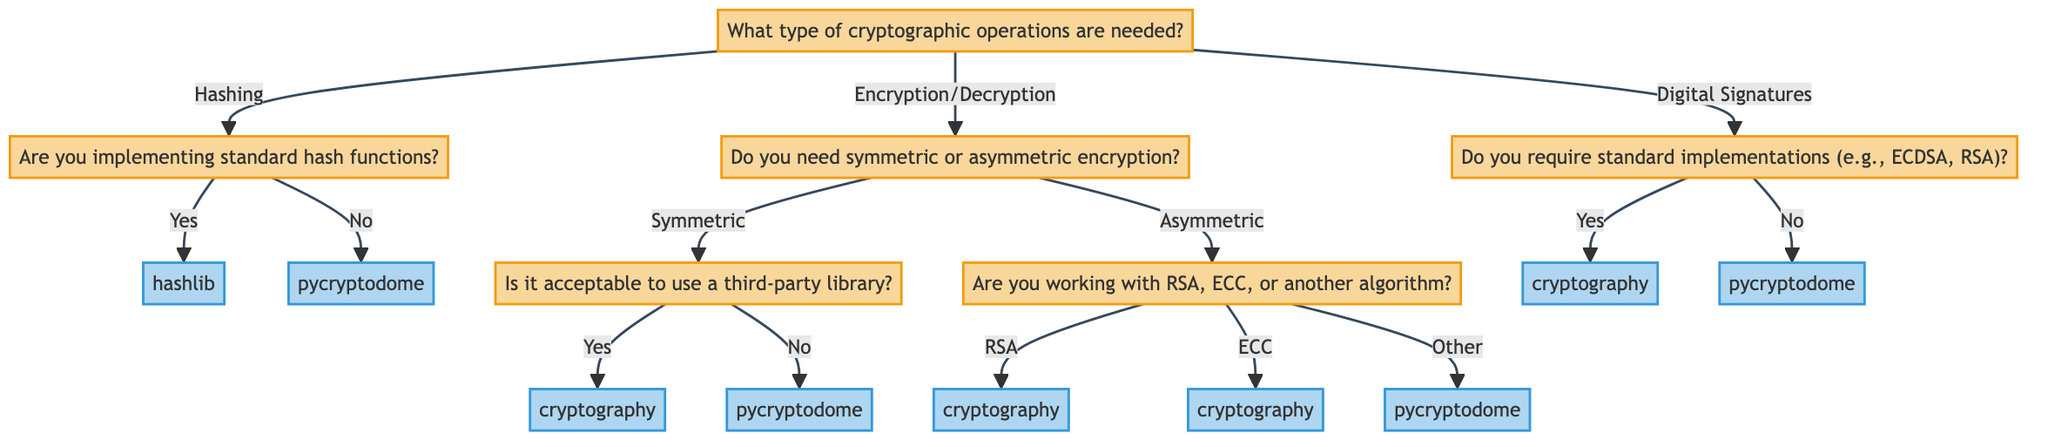What type of operations does the root node ask about? The root node asks about "What type of cryptographic operations are needed?" This is the first question directing the flow of the decision tree.
Answer: cryptographic operations What are the two main categories of encryption mentioned in this diagram? The options under "Do you need symmetric or asymmetric encryption?" are the two main categories of encryption presented at that decision point.
Answer: symmetric and asymmetric Which library is suggested for standard hash functions according to the diagram? If the user answers "Yes" to the question about implementing standard hash functions, the decision leads to the library "hashlib."
Answer: hashlib What is the justification for using the "cryptography" library for asymmetric encryption? Under the "Asymmetric" node, when the user selects "RSA" or "ECC," the decision leads to "cryptography" providing robust features and documentation for these algorithms.
Answer: Supports RSA with robust features and documentation If the user needs comprehensive support for symmetric encryption but does not want a third-party library, which library should they choose? The path progresses from "Do you need symmetric or asymmetric encryption?" to "Is it acceptable to use a third-party library?" If the user answers "No," it leads to the library "pycryptodome."
Answer: pycryptodome How many libraries are suggested for digital signature implementations in this decision tree? The digital signature section includes two libraries: "cryptography" and "pycryptodome," based on whether the user requires standard or non-standard implementations.
Answer: two What would be the output library if the user is implementing hashing but does not require standard hash functions? Following the flow from the hashing question to the "No" option, it leads to the library "pycryptodome," which offers a wider array of hashing functionalities.
Answer: pycryptodome How does the diagram categorize the requirement of standard digital signatures? It categorizes this requirement under the "Digital Signatures" section where it specifically asks if standard implementations are needed. "Yes" leads to "cryptography," while "No" leads to "pycryptodome."
Answer: standard implementations 